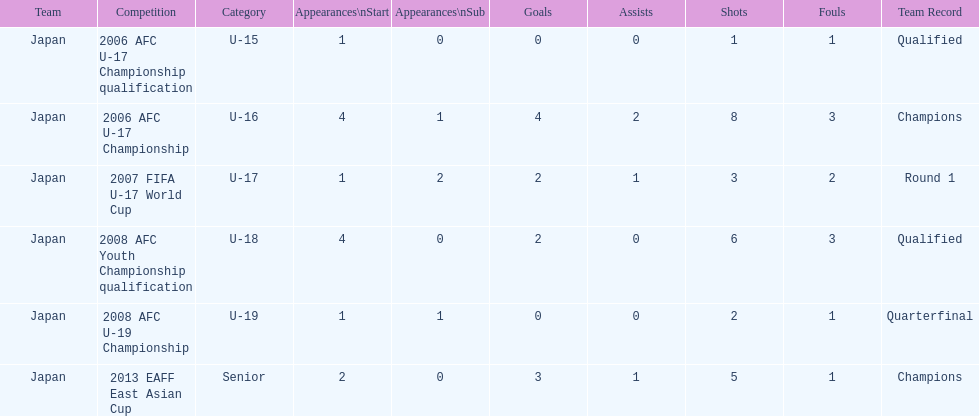In which two competitions did japan lack goals? 2006 AFC U-17 Championship qualification, 2008 AFC U-19 Championship. 